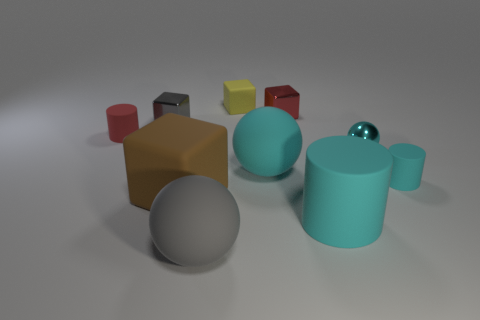What can you tell about the textures of the objects? Do they have a realistic appearance? The textures of the objects seem quite simple and lack the intricacies one might expect in a real-world setting. The smooth surfaces and somewhat uniform lighting give the objects a somewhat artificial appearance, akin to what you might find in a computer-generated or 3D-rendered scene designed for basic object recognition tasks or visual studies. 